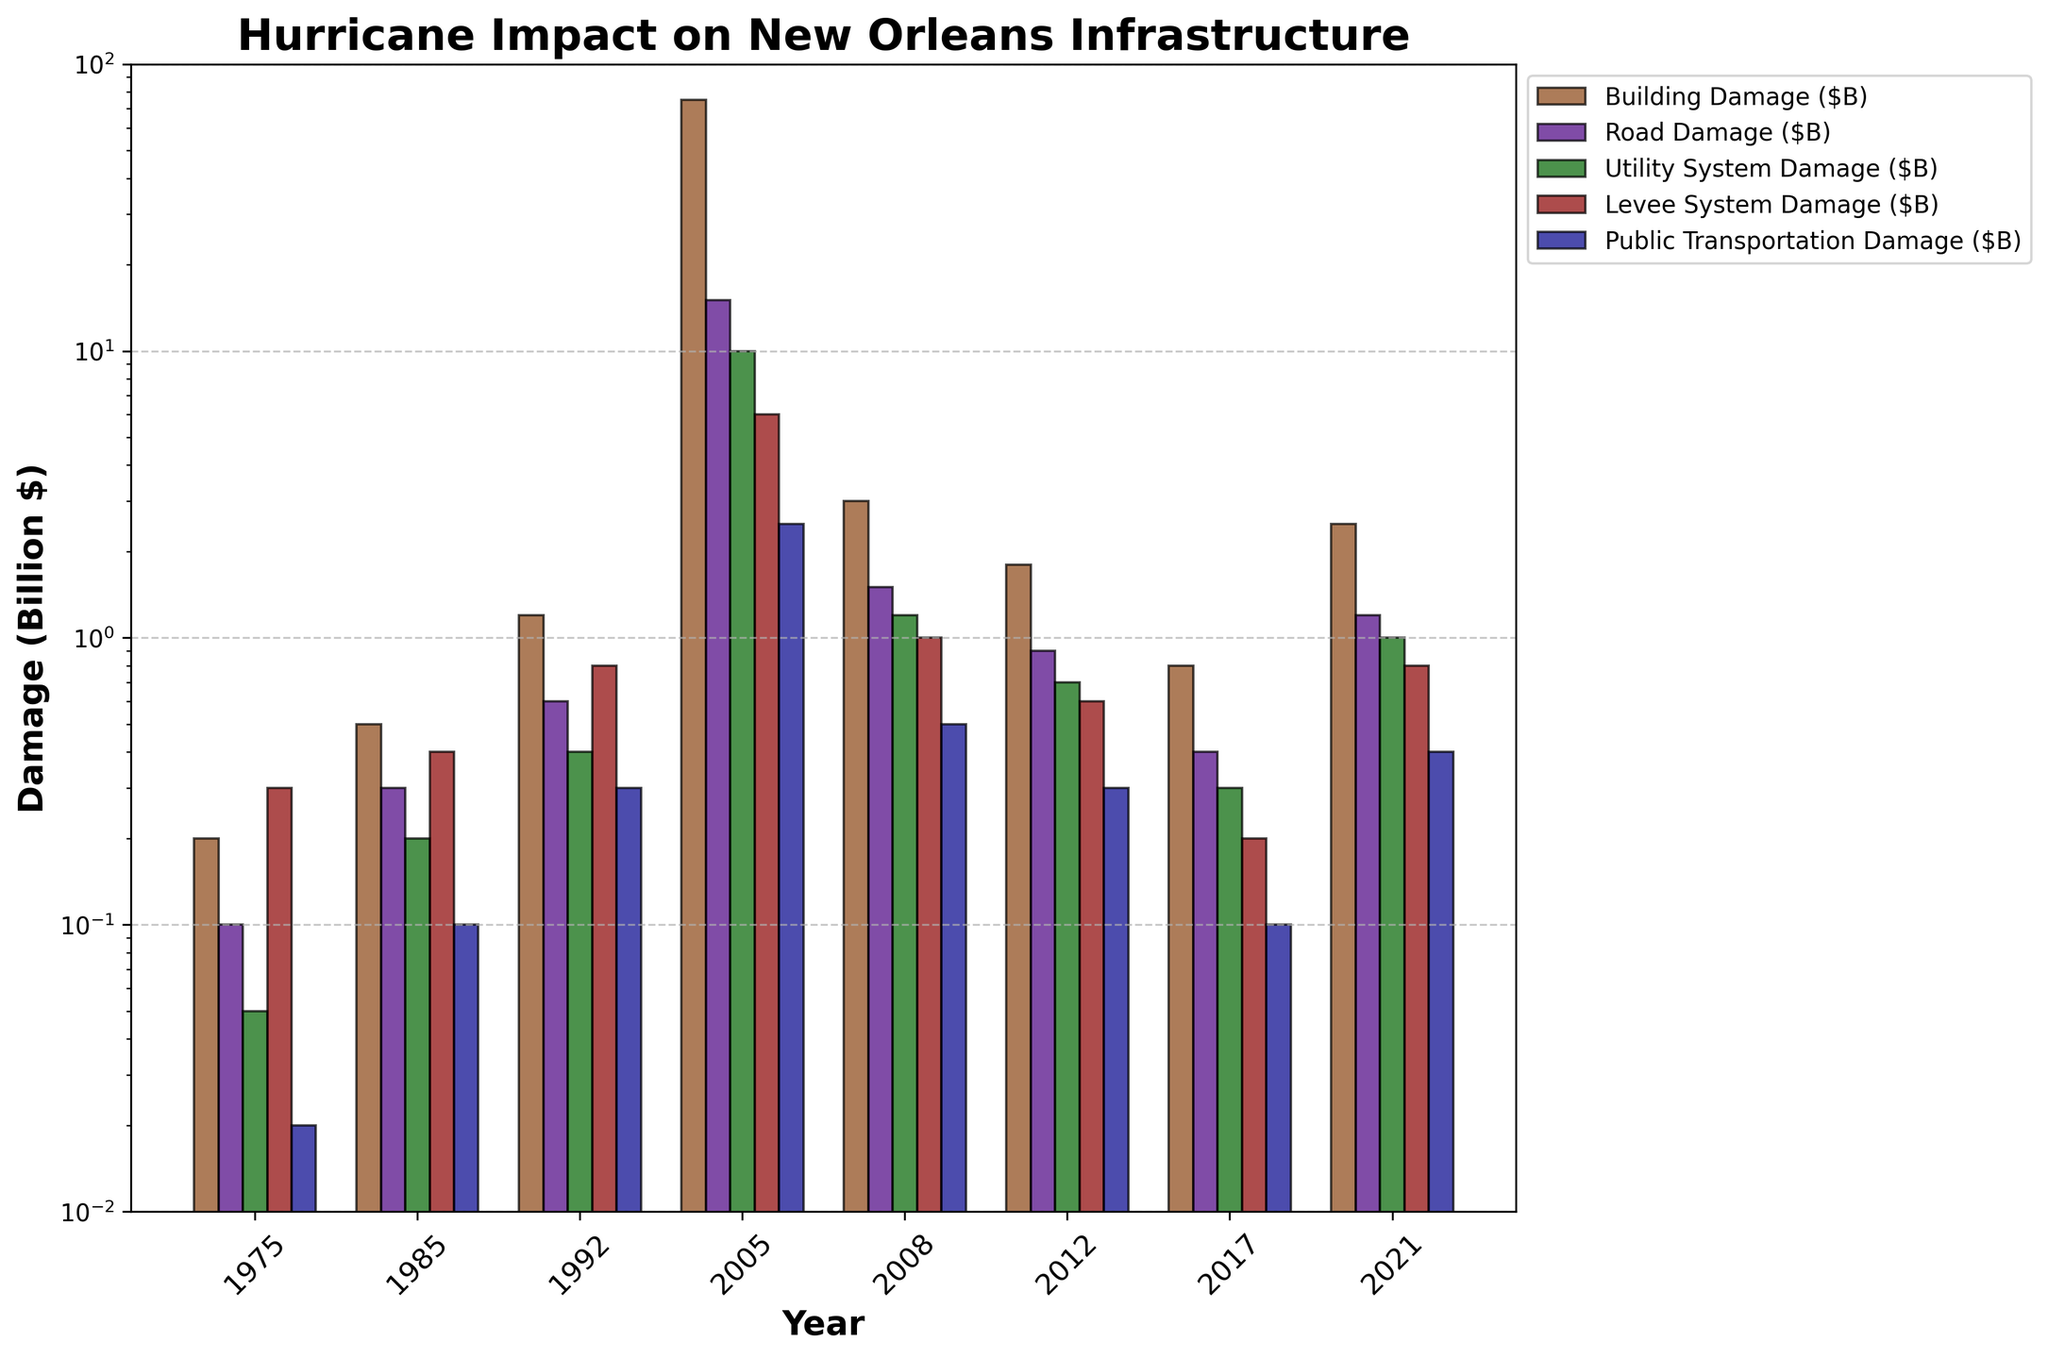1. Which year had the highest total damage across all categories? First, identify the total damage for each year by summing the values of all damage types. The year with the largest sum is 2005.
Answer: 2005 2. What is the difference in total damage between the years 2005 and 2008? Sum the values for each damage type for the years 2005 and 2008. Subtract the total damage of 2008 from 2005. The total damage for 2005 is 108.5 billion dollars and for 2008 is 7.2 billion dollars. The difference is 108.5 - 7.2 = 101.3 billion dollars.
Answer: 101.3 billion dollars 3. Which damage type had the lowest damage in 2005? Examine the bar representing 2005 and observe the lowest bar. Public Transportation Damage had the lowest damage in 2005.
Answer: Public Transportation Damage 4. How does the building damage in 2012 compare to 1975 in terms of magnitude? Compare the heights of the bars for Building Damage in 2012 and 1975. Building Damage in 2012 is significantly higher than in 1975.
Answer: Higher 5. In which year did Road Damage exceed 1 billion dollars for the first time? Check the bars for Road Damage across the years. The first year exceeding 1 billion dollars is 2005.
Answer: 2005 6. What is the total Levee System Damage across all years? Add up the values of Levee System Damage for all the years. The total is 0.3 + 0.4 + 0.8 + 6.0 + 1.0 + 0.6 + 0.2 + 0.8 = 10.1 billion dollars.
Answer: 10.1 billion dollars 7. Compared to 1985, is the Utility System Damage in 1992 higher or lower? Check the bars for Utility System Damage in both years. The damage in 1992 (0.4 billion dollars) is higher than in 1985 (0.2 billion dollars).
Answer: Higher 8. On a logarithmic scale, does the Building Damage in 1992 surpass Road Damage in 2017 visually? On a logarithmic scale, compare the heights of the Building Damage bar for 1992 and the Road Damage bar for 2017. Building Damage in 1992 visually surpasses Road Damage in 2017.
Answer: Yes 9. What is the median value of Building Damage across all years? Sort the Building Damage values and find the median: 0.2, 0.5, 0.8, 1.2, 1.8, 2.5, 3.0, 75.0. The median is the average of the 4th and 5th values (1.2 + 1.8) / 2 = 1.5 billion dollars.
Answer: 1.5 billion dollars 